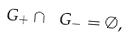Convert formula to latex. <formula><loc_0><loc_0><loc_500><loc_500>\ G _ { + } \cap \ G _ { - } = \emptyset ,</formula> 